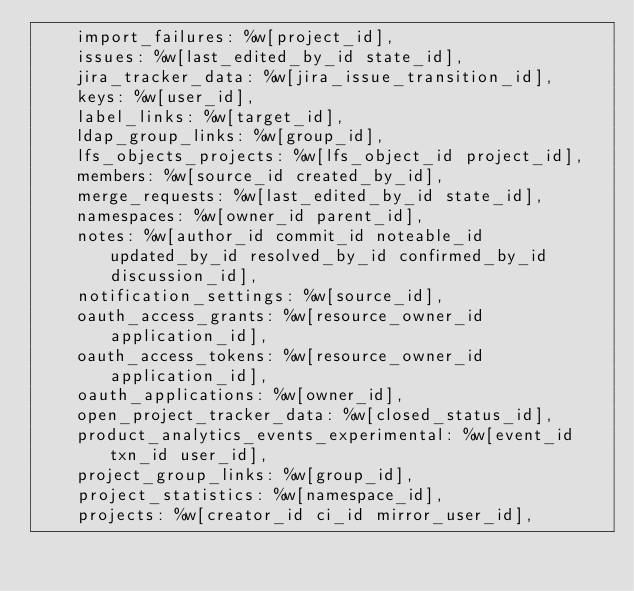<code> <loc_0><loc_0><loc_500><loc_500><_Ruby_>    import_failures: %w[project_id],
    issues: %w[last_edited_by_id state_id],
    jira_tracker_data: %w[jira_issue_transition_id],
    keys: %w[user_id],
    label_links: %w[target_id],
    ldap_group_links: %w[group_id],
    lfs_objects_projects: %w[lfs_object_id project_id],
    members: %w[source_id created_by_id],
    merge_requests: %w[last_edited_by_id state_id],
    namespaces: %w[owner_id parent_id],
    notes: %w[author_id commit_id noteable_id updated_by_id resolved_by_id confirmed_by_id discussion_id],
    notification_settings: %w[source_id],
    oauth_access_grants: %w[resource_owner_id application_id],
    oauth_access_tokens: %w[resource_owner_id application_id],
    oauth_applications: %w[owner_id],
    open_project_tracker_data: %w[closed_status_id],
    product_analytics_events_experimental: %w[event_id txn_id user_id],
    project_group_links: %w[group_id],
    project_statistics: %w[namespace_id],
    projects: %w[creator_id ci_id mirror_user_id],</code> 